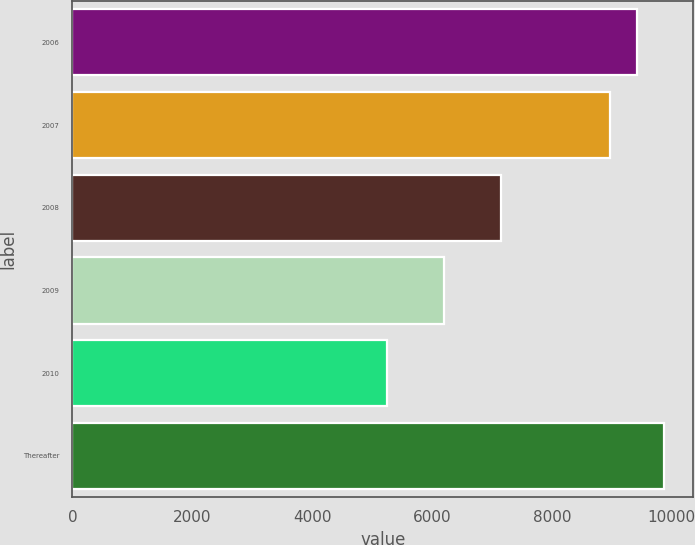Convert chart. <chart><loc_0><loc_0><loc_500><loc_500><bar_chart><fcel>2006<fcel>2007<fcel>2008<fcel>2009<fcel>2010<fcel>Thereafter<nl><fcel>9418.9<fcel>8969<fcel>7151<fcel>6202<fcel>5242<fcel>9868.8<nl></chart> 